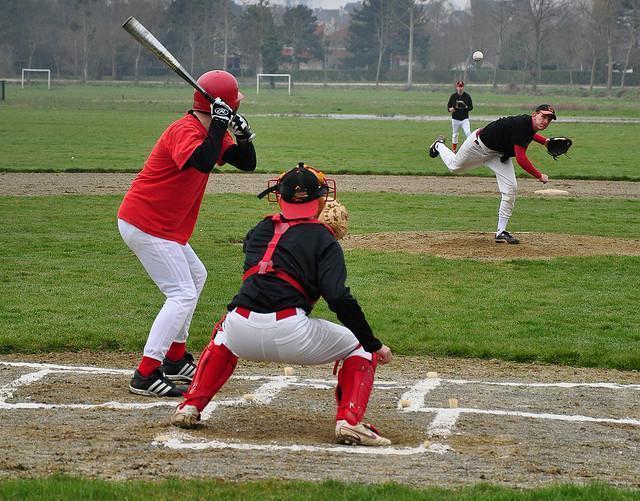What time of the year is it?
From the following set of four choices, select the accurate answer to respond to the question.
Options: Spring, solstice, summer, winter. Winter. 